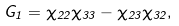<formula> <loc_0><loc_0><loc_500><loc_500>G _ { 1 } = \chi _ { 2 2 } \chi _ { 3 3 } - \chi _ { 2 3 } \chi _ { 3 2 } ,</formula> 